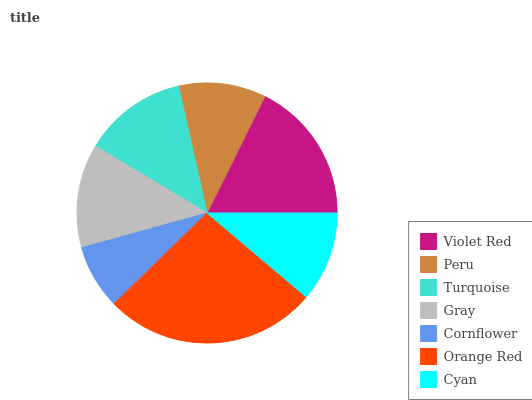Is Cornflower the minimum?
Answer yes or no. Yes. Is Orange Red the maximum?
Answer yes or no. Yes. Is Peru the minimum?
Answer yes or no. No. Is Peru the maximum?
Answer yes or no. No. Is Violet Red greater than Peru?
Answer yes or no. Yes. Is Peru less than Violet Red?
Answer yes or no. Yes. Is Peru greater than Violet Red?
Answer yes or no. No. Is Violet Red less than Peru?
Answer yes or no. No. Is Turquoise the high median?
Answer yes or no. Yes. Is Turquoise the low median?
Answer yes or no. Yes. Is Gray the high median?
Answer yes or no. No. Is Peru the low median?
Answer yes or no. No. 